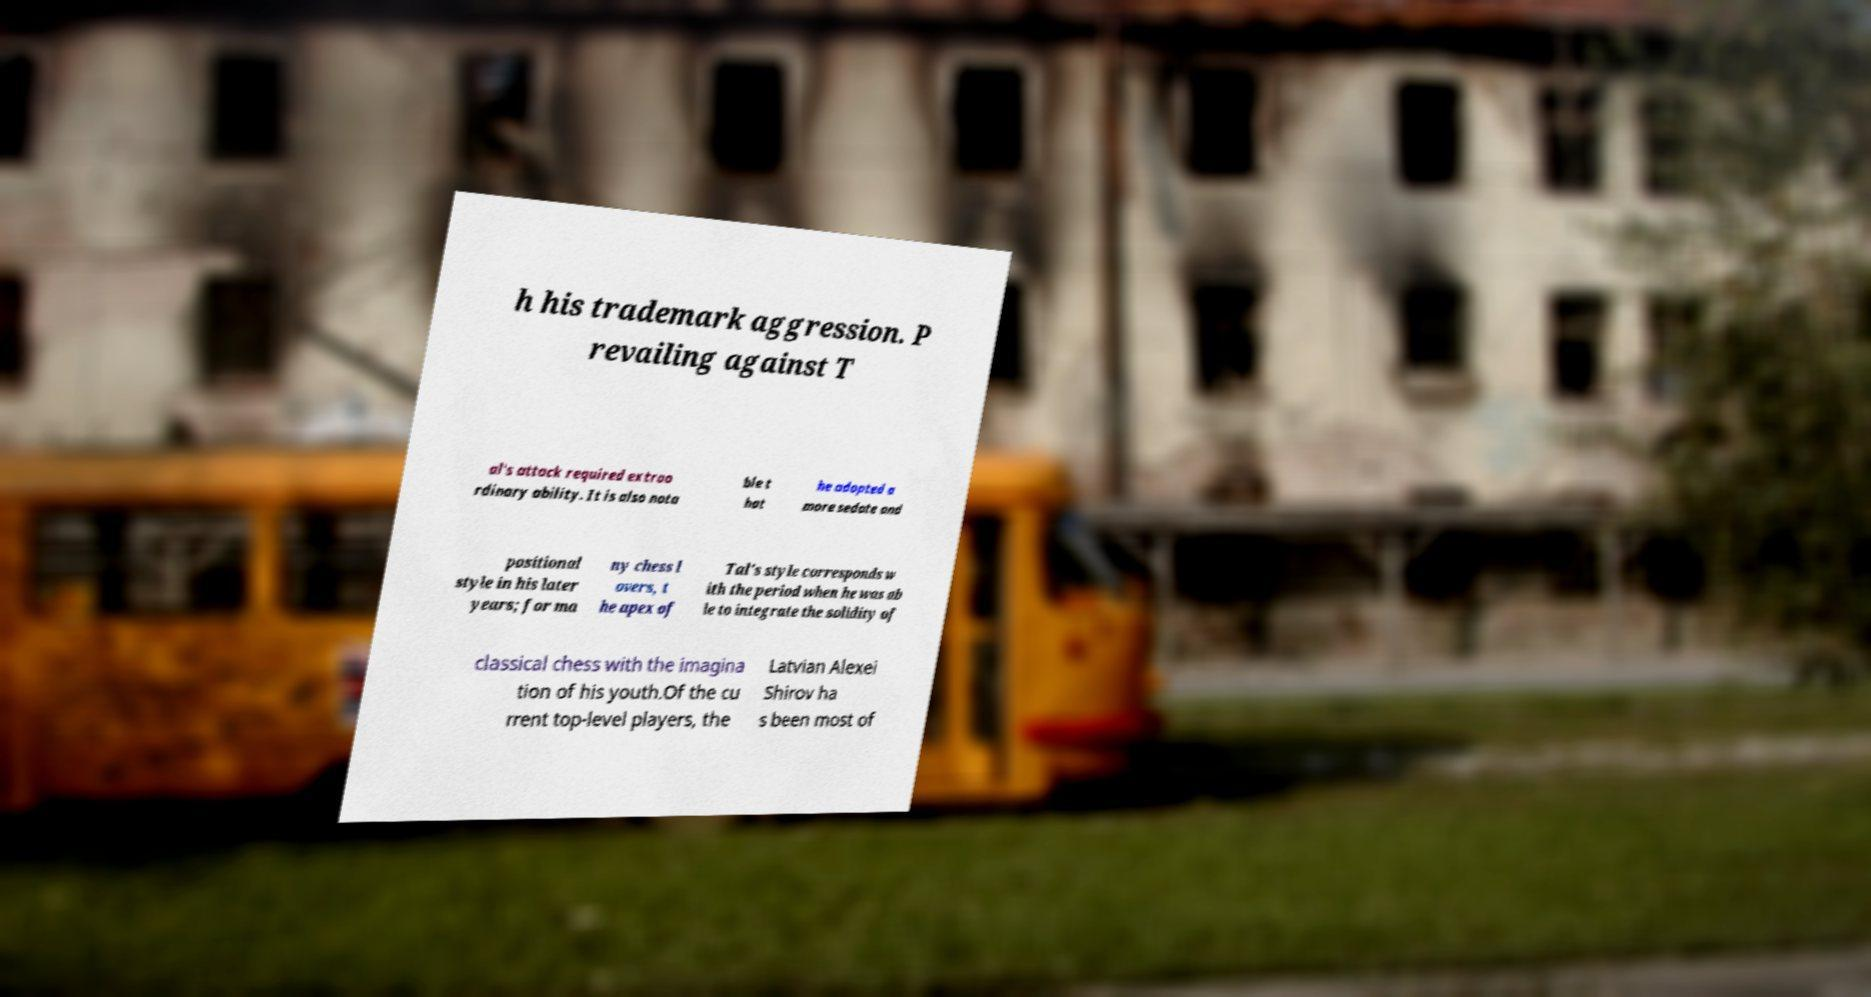Please read and relay the text visible in this image. What does it say? h his trademark aggression. P revailing against T al's attack required extrao rdinary ability. It is also nota ble t hat he adopted a more sedate and positional style in his later years; for ma ny chess l overs, t he apex of Tal's style corresponds w ith the period when he was ab le to integrate the solidity of classical chess with the imagina tion of his youth.Of the cu rrent top-level players, the Latvian Alexei Shirov ha s been most of 